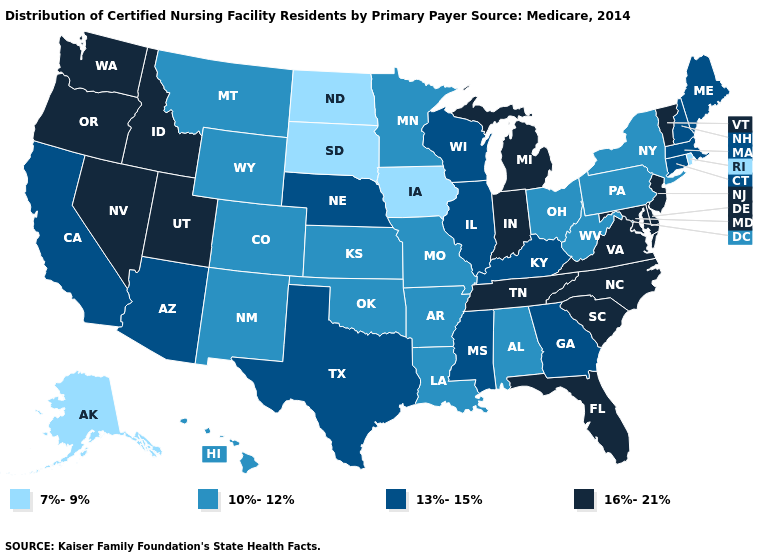Does the map have missing data?
Write a very short answer. No. Which states have the lowest value in the Northeast?
Keep it brief. Rhode Island. What is the value of Alabama?
Short answer required. 10%-12%. Which states hav the highest value in the South?
Be succinct. Delaware, Florida, Maryland, North Carolina, South Carolina, Tennessee, Virginia. Name the states that have a value in the range 16%-21%?
Give a very brief answer. Delaware, Florida, Idaho, Indiana, Maryland, Michigan, Nevada, New Jersey, North Carolina, Oregon, South Carolina, Tennessee, Utah, Vermont, Virginia, Washington. What is the value of Rhode Island?
Quick response, please. 7%-9%. Is the legend a continuous bar?
Answer briefly. No. What is the value of New Hampshire?
Short answer required. 13%-15%. Among the states that border Pennsylvania , does West Virginia have the highest value?
Give a very brief answer. No. Does the map have missing data?
Answer briefly. No. Does Maryland have a higher value than Georgia?
Write a very short answer. Yes. Name the states that have a value in the range 10%-12%?
Short answer required. Alabama, Arkansas, Colorado, Hawaii, Kansas, Louisiana, Minnesota, Missouri, Montana, New Mexico, New York, Ohio, Oklahoma, Pennsylvania, West Virginia, Wyoming. How many symbols are there in the legend?
Quick response, please. 4. Which states have the highest value in the USA?
Quick response, please. Delaware, Florida, Idaho, Indiana, Maryland, Michigan, Nevada, New Jersey, North Carolina, Oregon, South Carolina, Tennessee, Utah, Vermont, Virginia, Washington. Name the states that have a value in the range 10%-12%?
Answer briefly. Alabama, Arkansas, Colorado, Hawaii, Kansas, Louisiana, Minnesota, Missouri, Montana, New Mexico, New York, Ohio, Oklahoma, Pennsylvania, West Virginia, Wyoming. 